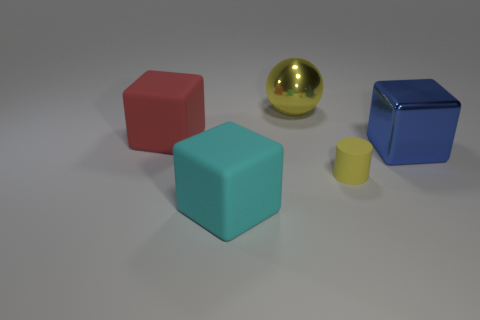Is there a big red thing made of the same material as the tiny object?
Your answer should be compact. Yes. There is a large metal object in front of the big red block; is there a large metal ball behind it?
Your response must be concise. Yes. There is a matte cube that is in front of the red cube; is its size the same as the red rubber thing?
Provide a short and direct response. Yes. What is the size of the cyan thing?
Give a very brief answer. Large. Are there any spheres of the same color as the small cylinder?
Give a very brief answer. Yes. How many tiny things are purple spheres or blue metal things?
Ensure brevity in your answer.  0. What is the size of the rubber object that is behind the cyan matte cube and to the left of the yellow cylinder?
Give a very brief answer. Large. There is a cyan thing; what number of tiny yellow cylinders are in front of it?
Give a very brief answer. 0. There is a matte object that is both to the left of the small yellow rubber cylinder and behind the cyan object; what shape is it?
Ensure brevity in your answer.  Cube. There is a object that is the same color as the metallic sphere; what material is it?
Give a very brief answer. Rubber. 